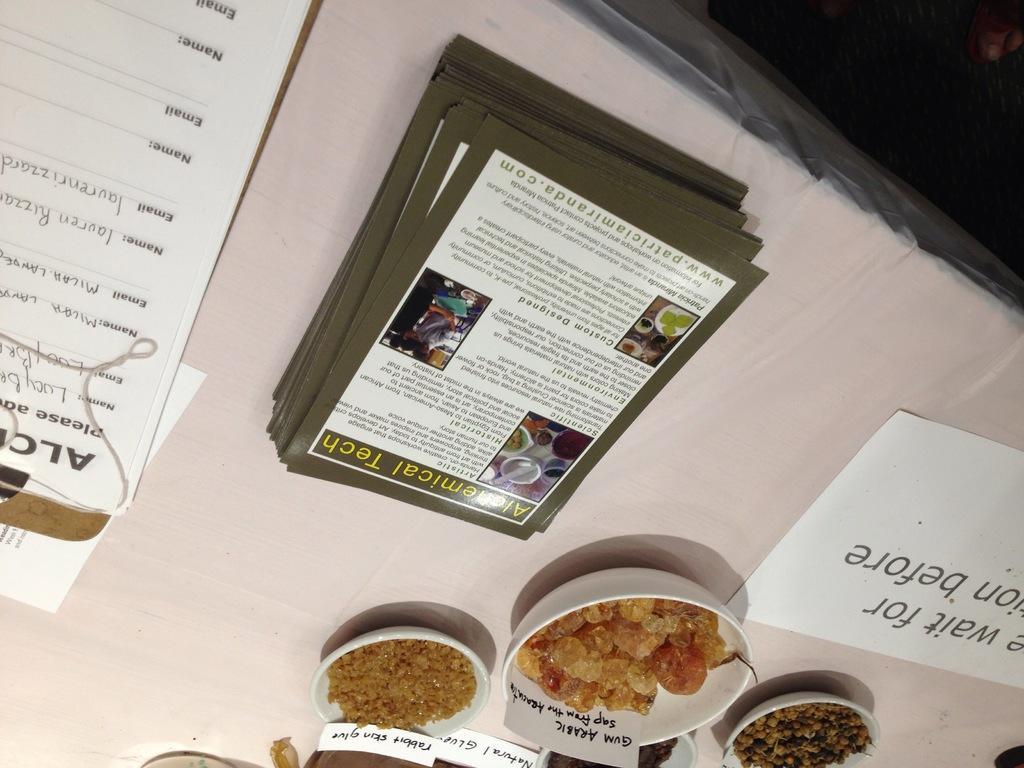Please provide a concise description of this image. In this image there is a table and we can see papers, bowls and some grains placed on the table. 